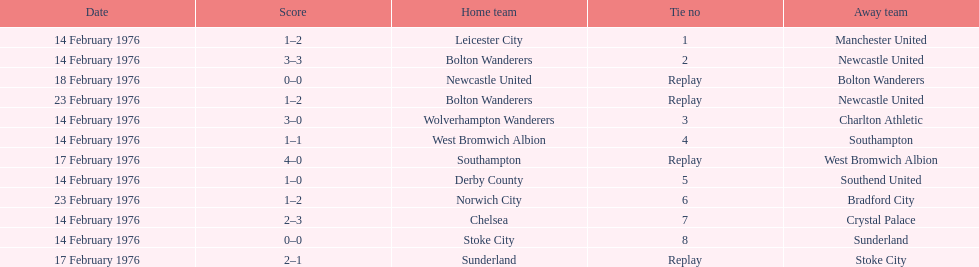How many teams played on february 14th, 1976? 7. 